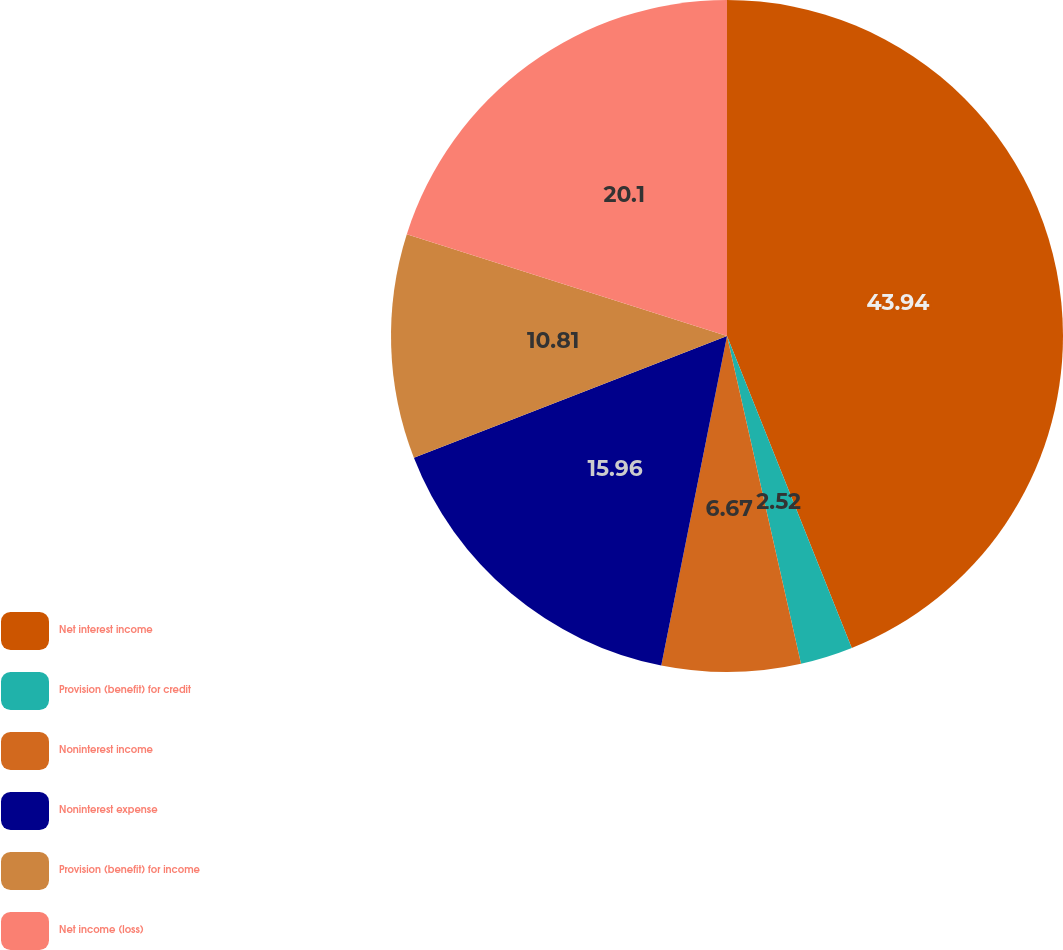Convert chart to OTSL. <chart><loc_0><loc_0><loc_500><loc_500><pie_chart><fcel>Net interest income<fcel>Provision (benefit) for credit<fcel>Noninterest income<fcel>Noninterest expense<fcel>Provision (benefit) for income<fcel>Net income (loss)<nl><fcel>43.95%<fcel>2.52%<fcel>6.67%<fcel>15.96%<fcel>10.81%<fcel>20.1%<nl></chart> 